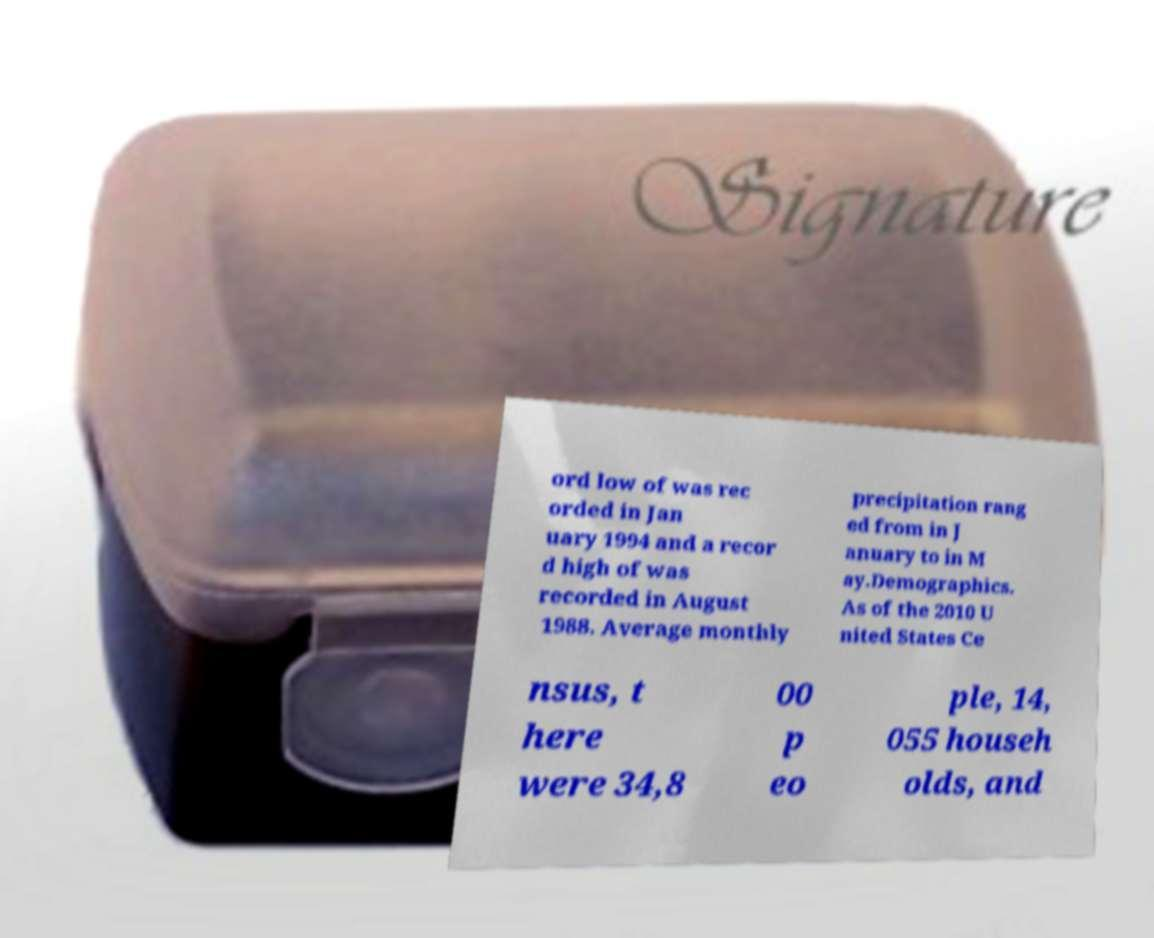I need the written content from this picture converted into text. Can you do that? ord low of was rec orded in Jan uary 1994 and a recor d high of was recorded in August 1988. Average monthly precipitation rang ed from in J anuary to in M ay.Demographics. As of the 2010 U nited States Ce nsus, t here were 34,8 00 p eo ple, 14, 055 househ olds, and 